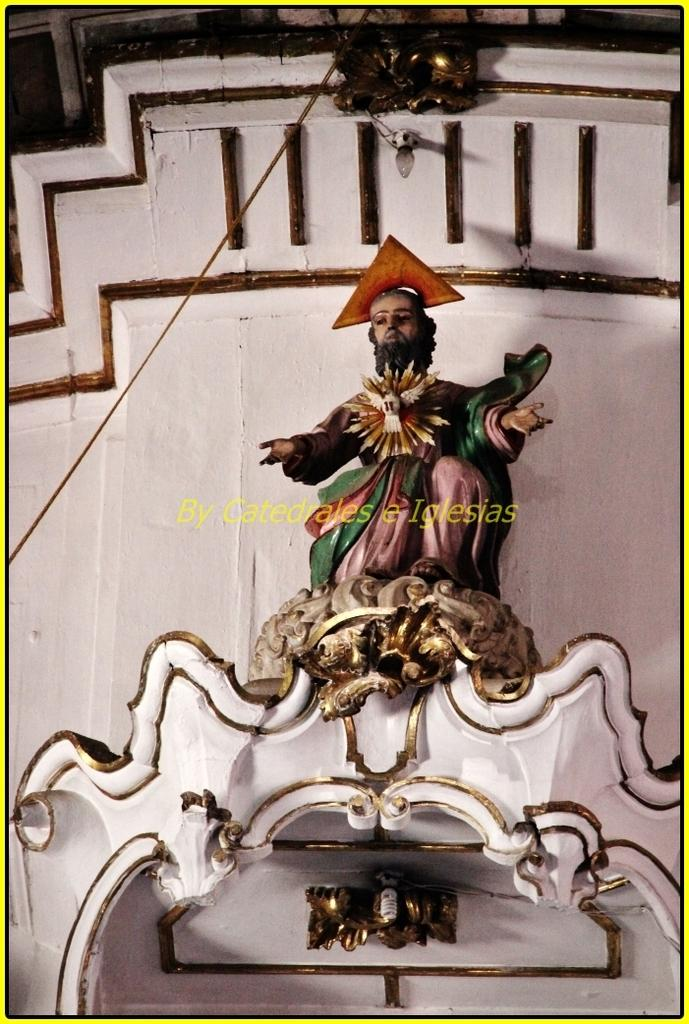What is located in the foreground of the image? There is a sculpture and a wall in the foreground of the image. Can you describe the cable in the image? It appears that there is a cable on the left and top of the image. What is attached to the wall at the top of the image? There is a bulb on the wall at the top of the image. What type of amusement park can be seen in the background of the image? There is no amusement park visible in the image; it only shows a sculpture, a wall, a cable, and a bulb. 